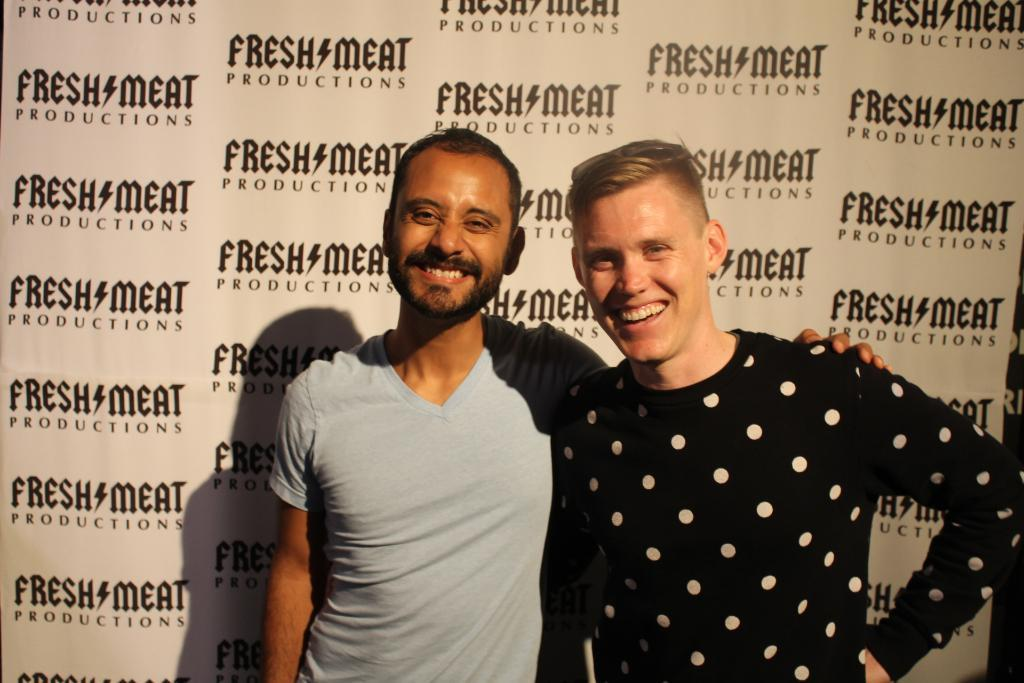How many men are present in the image? There are two men in the image. What are the men doing in the image? The men are standing. What can be seen in the background of the image? There is an advertisement in the background of the image. What type of pet can be seen sitting on the shoulder of one of the men in the image? There is no pet visible in the image; only the two men and an advertisement in the background are present. 